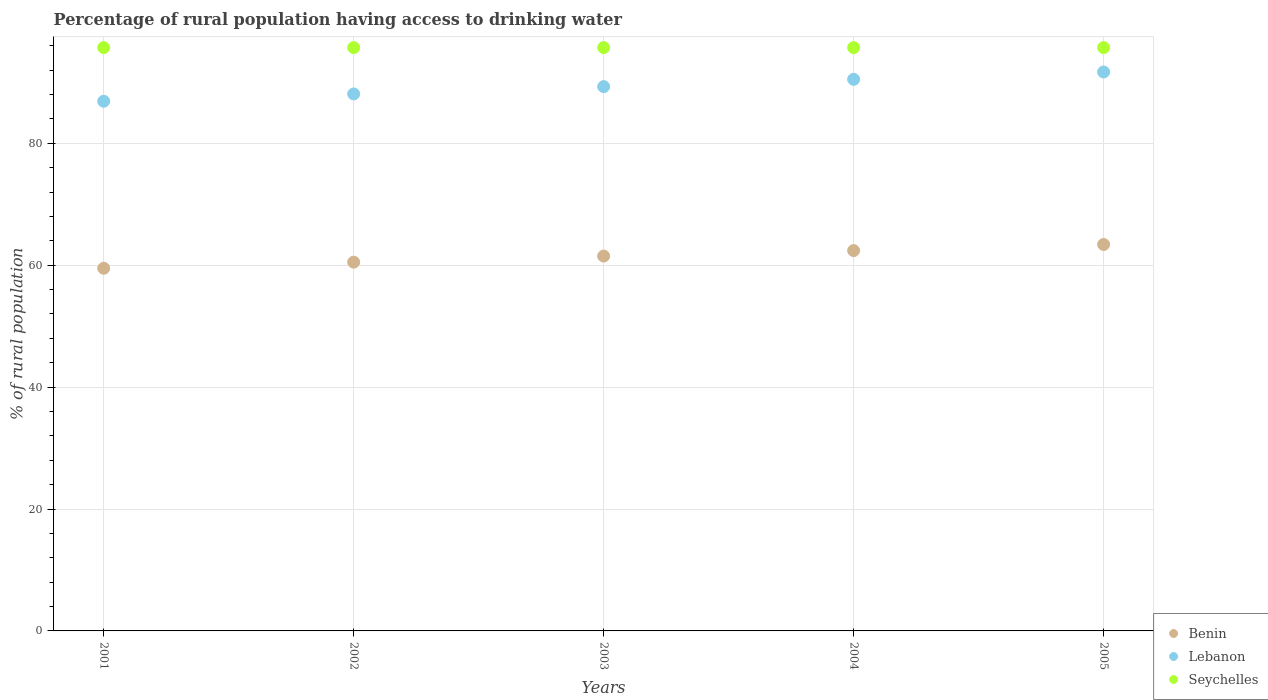Is the number of dotlines equal to the number of legend labels?
Provide a succinct answer. Yes. What is the percentage of rural population having access to drinking water in Benin in 2003?
Your answer should be compact. 61.5. Across all years, what is the maximum percentage of rural population having access to drinking water in Lebanon?
Your answer should be compact. 91.7. Across all years, what is the minimum percentage of rural population having access to drinking water in Benin?
Offer a terse response. 59.5. In which year was the percentage of rural population having access to drinking water in Lebanon maximum?
Make the answer very short. 2005. In which year was the percentage of rural population having access to drinking water in Benin minimum?
Offer a terse response. 2001. What is the total percentage of rural population having access to drinking water in Lebanon in the graph?
Make the answer very short. 446.5. What is the difference between the percentage of rural population having access to drinking water in Seychelles in 2002 and that in 2005?
Your response must be concise. 0. What is the difference between the percentage of rural population having access to drinking water in Lebanon in 2002 and the percentage of rural population having access to drinking water in Benin in 2005?
Offer a very short reply. 24.7. What is the average percentage of rural population having access to drinking water in Benin per year?
Ensure brevity in your answer.  61.46. In the year 2004, what is the difference between the percentage of rural population having access to drinking water in Lebanon and percentage of rural population having access to drinking water in Seychelles?
Your answer should be compact. -5.2. In how many years, is the percentage of rural population having access to drinking water in Seychelles greater than 76 %?
Ensure brevity in your answer.  5. What is the ratio of the percentage of rural population having access to drinking water in Seychelles in 2002 to that in 2005?
Offer a terse response. 1. Is the difference between the percentage of rural population having access to drinking water in Lebanon in 2002 and 2003 greater than the difference between the percentage of rural population having access to drinking water in Seychelles in 2002 and 2003?
Ensure brevity in your answer.  No. What is the difference between the highest and the second highest percentage of rural population having access to drinking water in Seychelles?
Your response must be concise. 0. What is the difference between the highest and the lowest percentage of rural population having access to drinking water in Lebanon?
Offer a terse response. 4.8. Is it the case that in every year, the sum of the percentage of rural population having access to drinking water in Lebanon and percentage of rural population having access to drinking water in Seychelles  is greater than the percentage of rural population having access to drinking water in Benin?
Make the answer very short. Yes. Are the values on the major ticks of Y-axis written in scientific E-notation?
Offer a very short reply. No. Does the graph contain any zero values?
Your answer should be compact. No. How are the legend labels stacked?
Give a very brief answer. Vertical. What is the title of the graph?
Ensure brevity in your answer.  Percentage of rural population having access to drinking water. What is the label or title of the Y-axis?
Offer a very short reply. % of rural population. What is the % of rural population in Benin in 2001?
Your answer should be very brief. 59.5. What is the % of rural population of Lebanon in 2001?
Your answer should be compact. 86.9. What is the % of rural population of Seychelles in 2001?
Offer a very short reply. 95.7. What is the % of rural population in Benin in 2002?
Make the answer very short. 60.5. What is the % of rural population in Lebanon in 2002?
Give a very brief answer. 88.1. What is the % of rural population in Seychelles in 2002?
Offer a terse response. 95.7. What is the % of rural population of Benin in 2003?
Provide a succinct answer. 61.5. What is the % of rural population of Lebanon in 2003?
Provide a short and direct response. 89.3. What is the % of rural population in Seychelles in 2003?
Your response must be concise. 95.7. What is the % of rural population of Benin in 2004?
Provide a short and direct response. 62.4. What is the % of rural population in Lebanon in 2004?
Your answer should be very brief. 90.5. What is the % of rural population of Seychelles in 2004?
Ensure brevity in your answer.  95.7. What is the % of rural population of Benin in 2005?
Your response must be concise. 63.4. What is the % of rural population in Lebanon in 2005?
Offer a very short reply. 91.7. What is the % of rural population in Seychelles in 2005?
Ensure brevity in your answer.  95.7. Across all years, what is the maximum % of rural population in Benin?
Offer a very short reply. 63.4. Across all years, what is the maximum % of rural population of Lebanon?
Make the answer very short. 91.7. Across all years, what is the maximum % of rural population of Seychelles?
Your answer should be very brief. 95.7. Across all years, what is the minimum % of rural population of Benin?
Ensure brevity in your answer.  59.5. Across all years, what is the minimum % of rural population of Lebanon?
Your answer should be very brief. 86.9. Across all years, what is the minimum % of rural population of Seychelles?
Make the answer very short. 95.7. What is the total % of rural population in Benin in the graph?
Your answer should be very brief. 307.3. What is the total % of rural population of Lebanon in the graph?
Offer a terse response. 446.5. What is the total % of rural population in Seychelles in the graph?
Provide a succinct answer. 478.5. What is the difference between the % of rural population of Benin in 2001 and that in 2002?
Ensure brevity in your answer.  -1. What is the difference between the % of rural population of Seychelles in 2001 and that in 2002?
Your response must be concise. 0. What is the difference between the % of rural population of Lebanon in 2001 and that in 2003?
Your answer should be compact. -2.4. What is the difference between the % of rural population in Lebanon in 2001 and that in 2004?
Ensure brevity in your answer.  -3.6. What is the difference between the % of rural population of Benin in 2001 and that in 2005?
Provide a succinct answer. -3.9. What is the difference between the % of rural population of Lebanon in 2001 and that in 2005?
Make the answer very short. -4.8. What is the difference between the % of rural population in Seychelles in 2001 and that in 2005?
Make the answer very short. 0. What is the difference between the % of rural population in Seychelles in 2002 and that in 2003?
Offer a terse response. 0. What is the difference between the % of rural population of Benin in 2002 and that in 2004?
Give a very brief answer. -1.9. What is the difference between the % of rural population of Seychelles in 2002 and that in 2004?
Your answer should be very brief. 0. What is the difference between the % of rural population in Seychelles in 2003 and that in 2004?
Provide a succinct answer. 0. What is the difference between the % of rural population in Benin in 2003 and that in 2005?
Offer a very short reply. -1.9. What is the difference between the % of rural population in Lebanon in 2003 and that in 2005?
Keep it short and to the point. -2.4. What is the difference between the % of rural population of Seychelles in 2003 and that in 2005?
Make the answer very short. 0. What is the difference between the % of rural population in Lebanon in 2004 and that in 2005?
Your answer should be compact. -1.2. What is the difference between the % of rural population in Benin in 2001 and the % of rural population in Lebanon in 2002?
Make the answer very short. -28.6. What is the difference between the % of rural population of Benin in 2001 and the % of rural population of Seychelles in 2002?
Provide a succinct answer. -36.2. What is the difference between the % of rural population of Benin in 2001 and the % of rural population of Lebanon in 2003?
Your answer should be compact. -29.8. What is the difference between the % of rural population in Benin in 2001 and the % of rural population in Seychelles in 2003?
Your answer should be very brief. -36.2. What is the difference between the % of rural population in Lebanon in 2001 and the % of rural population in Seychelles in 2003?
Keep it short and to the point. -8.8. What is the difference between the % of rural population in Benin in 2001 and the % of rural population in Lebanon in 2004?
Your answer should be compact. -31. What is the difference between the % of rural population in Benin in 2001 and the % of rural population in Seychelles in 2004?
Offer a terse response. -36.2. What is the difference between the % of rural population in Benin in 2001 and the % of rural population in Lebanon in 2005?
Offer a terse response. -32.2. What is the difference between the % of rural population in Benin in 2001 and the % of rural population in Seychelles in 2005?
Keep it short and to the point. -36.2. What is the difference between the % of rural population in Lebanon in 2001 and the % of rural population in Seychelles in 2005?
Your response must be concise. -8.8. What is the difference between the % of rural population of Benin in 2002 and the % of rural population of Lebanon in 2003?
Your response must be concise. -28.8. What is the difference between the % of rural population in Benin in 2002 and the % of rural population in Seychelles in 2003?
Offer a terse response. -35.2. What is the difference between the % of rural population in Lebanon in 2002 and the % of rural population in Seychelles in 2003?
Ensure brevity in your answer.  -7.6. What is the difference between the % of rural population in Benin in 2002 and the % of rural population in Seychelles in 2004?
Your answer should be very brief. -35.2. What is the difference between the % of rural population in Benin in 2002 and the % of rural population in Lebanon in 2005?
Offer a terse response. -31.2. What is the difference between the % of rural population in Benin in 2002 and the % of rural population in Seychelles in 2005?
Your answer should be very brief. -35.2. What is the difference between the % of rural population of Lebanon in 2002 and the % of rural population of Seychelles in 2005?
Offer a very short reply. -7.6. What is the difference between the % of rural population of Benin in 2003 and the % of rural population of Lebanon in 2004?
Your response must be concise. -29. What is the difference between the % of rural population of Benin in 2003 and the % of rural population of Seychelles in 2004?
Offer a very short reply. -34.2. What is the difference between the % of rural population in Lebanon in 2003 and the % of rural population in Seychelles in 2004?
Keep it short and to the point. -6.4. What is the difference between the % of rural population of Benin in 2003 and the % of rural population of Lebanon in 2005?
Make the answer very short. -30.2. What is the difference between the % of rural population of Benin in 2003 and the % of rural population of Seychelles in 2005?
Offer a terse response. -34.2. What is the difference between the % of rural population of Lebanon in 2003 and the % of rural population of Seychelles in 2005?
Your answer should be compact. -6.4. What is the difference between the % of rural population in Benin in 2004 and the % of rural population in Lebanon in 2005?
Provide a succinct answer. -29.3. What is the difference between the % of rural population in Benin in 2004 and the % of rural population in Seychelles in 2005?
Keep it short and to the point. -33.3. What is the difference between the % of rural population in Lebanon in 2004 and the % of rural population in Seychelles in 2005?
Keep it short and to the point. -5.2. What is the average % of rural population of Benin per year?
Provide a short and direct response. 61.46. What is the average % of rural population of Lebanon per year?
Your answer should be compact. 89.3. What is the average % of rural population in Seychelles per year?
Ensure brevity in your answer.  95.7. In the year 2001, what is the difference between the % of rural population in Benin and % of rural population in Lebanon?
Your answer should be compact. -27.4. In the year 2001, what is the difference between the % of rural population of Benin and % of rural population of Seychelles?
Your answer should be very brief. -36.2. In the year 2002, what is the difference between the % of rural population in Benin and % of rural population in Lebanon?
Offer a very short reply. -27.6. In the year 2002, what is the difference between the % of rural population of Benin and % of rural population of Seychelles?
Give a very brief answer. -35.2. In the year 2002, what is the difference between the % of rural population of Lebanon and % of rural population of Seychelles?
Your answer should be compact. -7.6. In the year 2003, what is the difference between the % of rural population of Benin and % of rural population of Lebanon?
Your answer should be very brief. -27.8. In the year 2003, what is the difference between the % of rural population of Benin and % of rural population of Seychelles?
Your answer should be compact. -34.2. In the year 2004, what is the difference between the % of rural population of Benin and % of rural population of Lebanon?
Keep it short and to the point. -28.1. In the year 2004, what is the difference between the % of rural population in Benin and % of rural population in Seychelles?
Keep it short and to the point. -33.3. In the year 2005, what is the difference between the % of rural population of Benin and % of rural population of Lebanon?
Give a very brief answer. -28.3. In the year 2005, what is the difference between the % of rural population of Benin and % of rural population of Seychelles?
Give a very brief answer. -32.3. What is the ratio of the % of rural population in Benin in 2001 to that in 2002?
Provide a succinct answer. 0.98. What is the ratio of the % of rural population in Lebanon in 2001 to that in 2002?
Keep it short and to the point. 0.99. What is the ratio of the % of rural population of Seychelles in 2001 to that in 2002?
Keep it short and to the point. 1. What is the ratio of the % of rural population in Benin in 2001 to that in 2003?
Give a very brief answer. 0.97. What is the ratio of the % of rural population in Lebanon in 2001 to that in 2003?
Provide a short and direct response. 0.97. What is the ratio of the % of rural population of Benin in 2001 to that in 2004?
Offer a very short reply. 0.95. What is the ratio of the % of rural population in Lebanon in 2001 to that in 2004?
Provide a short and direct response. 0.96. What is the ratio of the % of rural population in Seychelles in 2001 to that in 2004?
Make the answer very short. 1. What is the ratio of the % of rural population of Benin in 2001 to that in 2005?
Make the answer very short. 0.94. What is the ratio of the % of rural population of Lebanon in 2001 to that in 2005?
Give a very brief answer. 0.95. What is the ratio of the % of rural population of Benin in 2002 to that in 2003?
Keep it short and to the point. 0.98. What is the ratio of the % of rural population of Lebanon in 2002 to that in 2003?
Offer a terse response. 0.99. What is the ratio of the % of rural population in Benin in 2002 to that in 2004?
Keep it short and to the point. 0.97. What is the ratio of the % of rural population of Lebanon in 2002 to that in 2004?
Give a very brief answer. 0.97. What is the ratio of the % of rural population in Seychelles in 2002 to that in 2004?
Offer a very short reply. 1. What is the ratio of the % of rural population of Benin in 2002 to that in 2005?
Offer a very short reply. 0.95. What is the ratio of the % of rural population of Lebanon in 2002 to that in 2005?
Provide a succinct answer. 0.96. What is the ratio of the % of rural population in Seychelles in 2002 to that in 2005?
Keep it short and to the point. 1. What is the ratio of the % of rural population in Benin in 2003 to that in 2004?
Your response must be concise. 0.99. What is the ratio of the % of rural population of Lebanon in 2003 to that in 2004?
Give a very brief answer. 0.99. What is the ratio of the % of rural population in Seychelles in 2003 to that in 2004?
Make the answer very short. 1. What is the ratio of the % of rural population in Benin in 2003 to that in 2005?
Your answer should be very brief. 0.97. What is the ratio of the % of rural population in Lebanon in 2003 to that in 2005?
Provide a succinct answer. 0.97. What is the ratio of the % of rural population in Benin in 2004 to that in 2005?
Offer a terse response. 0.98. What is the ratio of the % of rural population in Lebanon in 2004 to that in 2005?
Offer a very short reply. 0.99. What is the ratio of the % of rural population in Seychelles in 2004 to that in 2005?
Provide a short and direct response. 1. What is the difference between the highest and the second highest % of rural population in Benin?
Provide a succinct answer. 1. What is the difference between the highest and the second highest % of rural population of Seychelles?
Offer a very short reply. 0. What is the difference between the highest and the lowest % of rural population in Benin?
Your response must be concise. 3.9. 